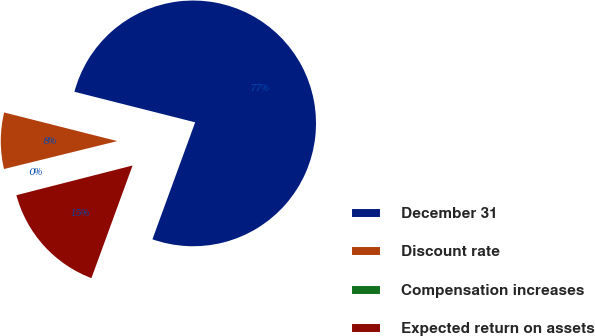Convert chart. <chart><loc_0><loc_0><loc_500><loc_500><pie_chart><fcel>December 31<fcel>Discount rate<fcel>Compensation increases<fcel>Expected return on assets<nl><fcel>76.63%<fcel>7.79%<fcel>0.14%<fcel>15.44%<nl></chart> 